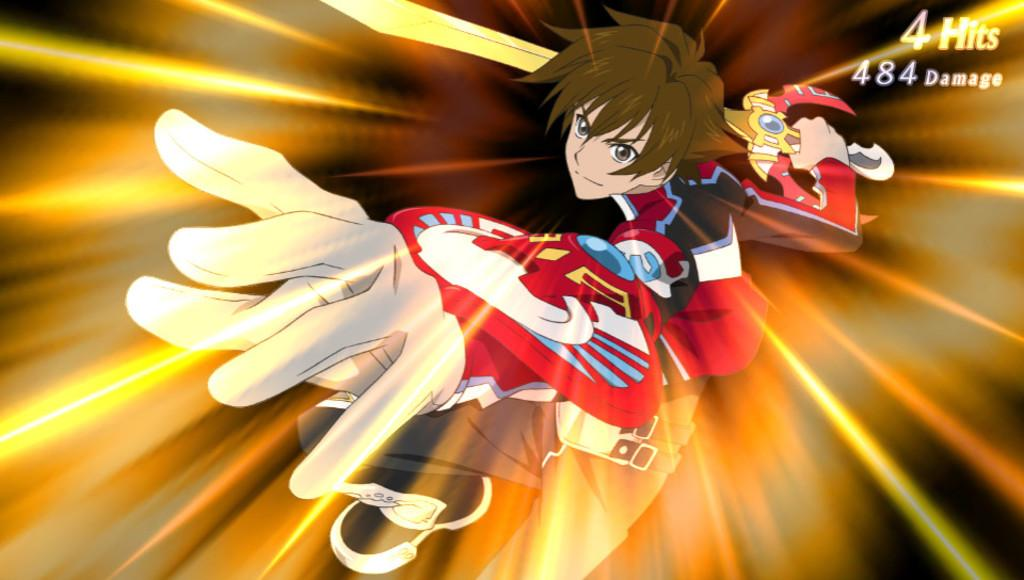What type of image is in the picture? There is an anime image in the picture. What character is depicted in the anime image? The image depicts a boy. What is the boy wearing? The boy is wearing a red dress. What object is the boy holding in his hand? The boy is holding a sword in his hand. What type of van can be seen in the background of the image? There is no van present in the image; it features an anime image of a boy wearing a red dress and holding a sword. 